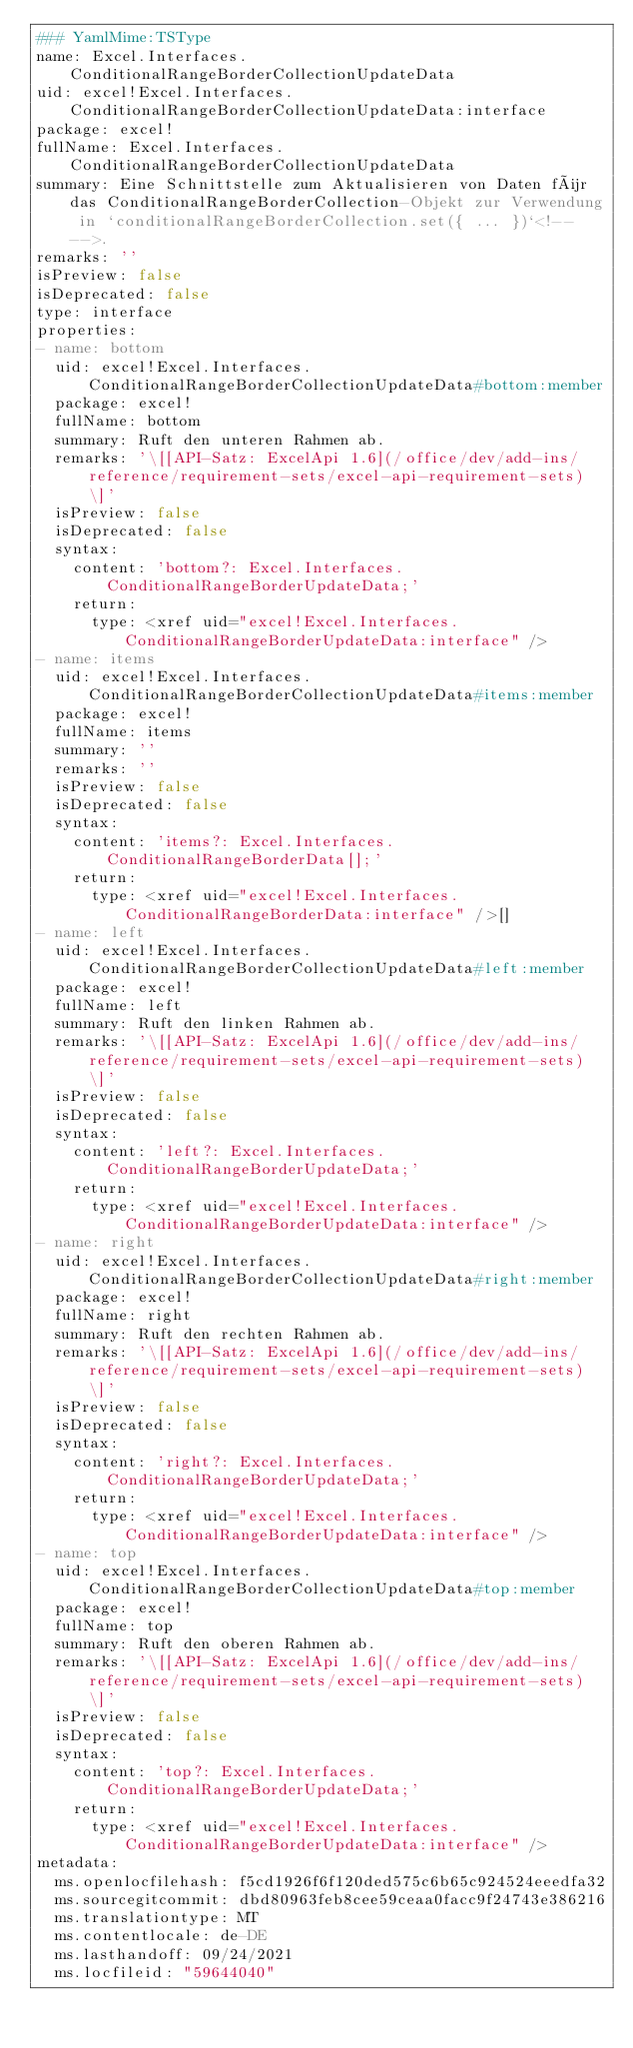Convert code to text. <code><loc_0><loc_0><loc_500><loc_500><_YAML_>### YamlMime:TSType
name: Excel.Interfaces.ConditionalRangeBorderCollectionUpdateData
uid: excel!Excel.Interfaces.ConditionalRangeBorderCollectionUpdateData:interface
package: excel!
fullName: Excel.Interfaces.ConditionalRangeBorderCollectionUpdateData
summary: Eine Schnittstelle zum Aktualisieren von Daten für das ConditionalRangeBorderCollection-Objekt zur Verwendung in `conditionalRangeBorderCollection.set({ ... })`<!-- -->.
remarks: ''
isPreview: false
isDeprecated: false
type: interface
properties:
- name: bottom
  uid: excel!Excel.Interfaces.ConditionalRangeBorderCollectionUpdateData#bottom:member
  package: excel!
  fullName: bottom
  summary: Ruft den unteren Rahmen ab.
  remarks: '\[[API-Satz: ExcelApi 1.6](/office/dev/add-ins/reference/requirement-sets/excel-api-requirement-sets) \]'
  isPreview: false
  isDeprecated: false
  syntax:
    content: 'bottom?: Excel.Interfaces.ConditionalRangeBorderUpdateData;'
    return:
      type: <xref uid="excel!Excel.Interfaces.ConditionalRangeBorderUpdateData:interface" />
- name: items
  uid: excel!Excel.Interfaces.ConditionalRangeBorderCollectionUpdateData#items:member
  package: excel!
  fullName: items
  summary: ''
  remarks: ''
  isPreview: false
  isDeprecated: false
  syntax:
    content: 'items?: Excel.Interfaces.ConditionalRangeBorderData[];'
    return:
      type: <xref uid="excel!Excel.Interfaces.ConditionalRangeBorderData:interface" />[]
- name: left
  uid: excel!Excel.Interfaces.ConditionalRangeBorderCollectionUpdateData#left:member
  package: excel!
  fullName: left
  summary: Ruft den linken Rahmen ab.
  remarks: '\[[API-Satz: ExcelApi 1.6](/office/dev/add-ins/reference/requirement-sets/excel-api-requirement-sets) \]'
  isPreview: false
  isDeprecated: false
  syntax:
    content: 'left?: Excel.Interfaces.ConditionalRangeBorderUpdateData;'
    return:
      type: <xref uid="excel!Excel.Interfaces.ConditionalRangeBorderUpdateData:interface" />
- name: right
  uid: excel!Excel.Interfaces.ConditionalRangeBorderCollectionUpdateData#right:member
  package: excel!
  fullName: right
  summary: Ruft den rechten Rahmen ab.
  remarks: '\[[API-Satz: ExcelApi 1.6](/office/dev/add-ins/reference/requirement-sets/excel-api-requirement-sets) \]'
  isPreview: false
  isDeprecated: false
  syntax:
    content: 'right?: Excel.Interfaces.ConditionalRangeBorderUpdateData;'
    return:
      type: <xref uid="excel!Excel.Interfaces.ConditionalRangeBorderUpdateData:interface" />
- name: top
  uid: excel!Excel.Interfaces.ConditionalRangeBorderCollectionUpdateData#top:member
  package: excel!
  fullName: top
  summary: Ruft den oberen Rahmen ab.
  remarks: '\[[API-Satz: ExcelApi 1.6](/office/dev/add-ins/reference/requirement-sets/excel-api-requirement-sets) \]'
  isPreview: false
  isDeprecated: false
  syntax:
    content: 'top?: Excel.Interfaces.ConditionalRangeBorderUpdateData;'
    return:
      type: <xref uid="excel!Excel.Interfaces.ConditionalRangeBorderUpdateData:interface" />
metadata:
  ms.openlocfilehash: f5cd1926f6f120ded575c6b65c924524eeedfa32
  ms.sourcegitcommit: dbd80963feb8cee59ceaa0facc9f24743e386216
  ms.translationtype: MT
  ms.contentlocale: de-DE
  ms.lasthandoff: 09/24/2021
  ms.locfileid: "59644040"
</code> 